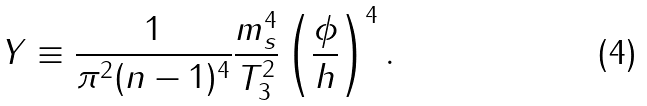Convert formula to latex. <formula><loc_0><loc_0><loc_500><loc_500>Y \equiv \frac { 1 } { \pi ^ { 2 } ( n - 1 ) ^ { 4 } } \frac { m _ { s } ^ { 4 } } { T _ { 3 } ^ { 2 } } \left ( \frac { \phi } { h } \right ) ^ { 4 } .</formula> 